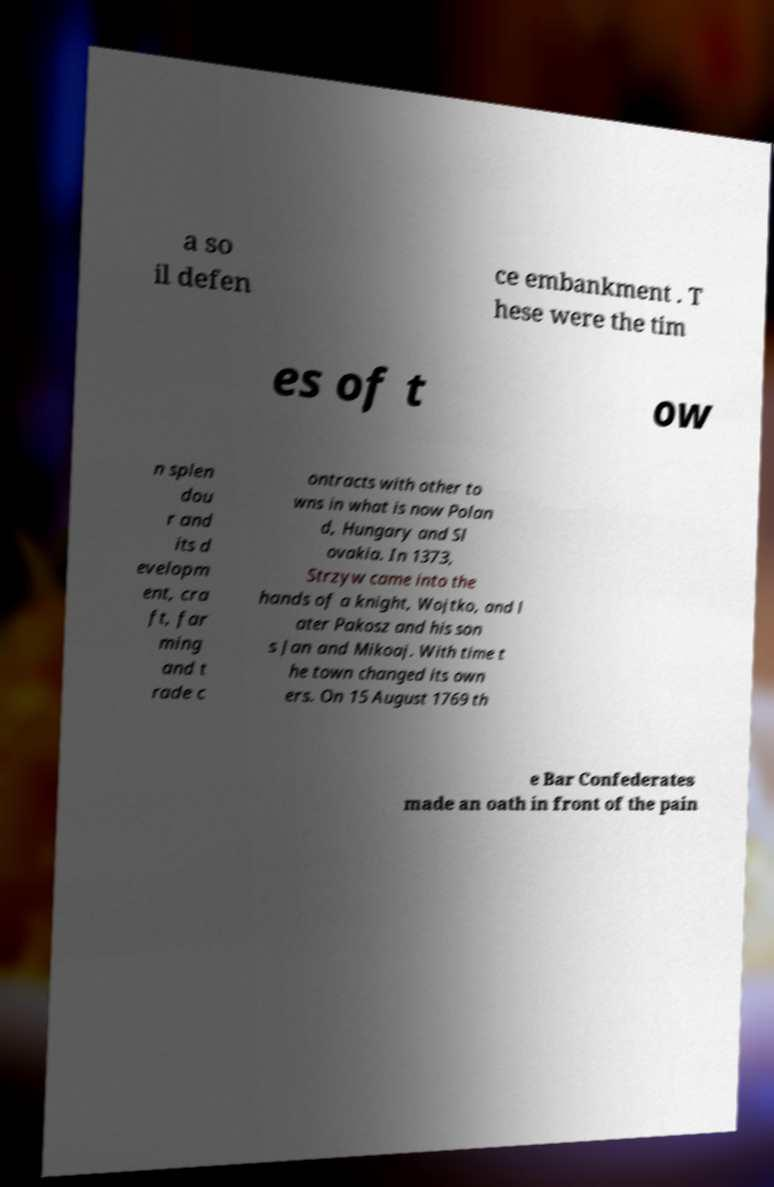Can you read and provide the text displayed in the image?This photo seems to have some interesting text. Can you extract and type it out for me? a so il defen ce embankment . T hese were the tim es of t ow n splen dou r and its d evelopm ent, cra ft, far ming and t rade c ontracts with other to wns in what is now Polan d, Hungary and Sl ovakia. In 1373, Strzyw came into the hands of a knight, Wojtko, and l ater Pakosz and his son s Jan and Mikoaj. With time t he town changed its own ers. On 15 August 1769 th e Bar Confederates made an oath in front of the pain 